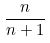Convert formula to latex. <formula><loc_0><loc_0><loc_500><loc_500>\frac { n } { n + 1 }</formula> 